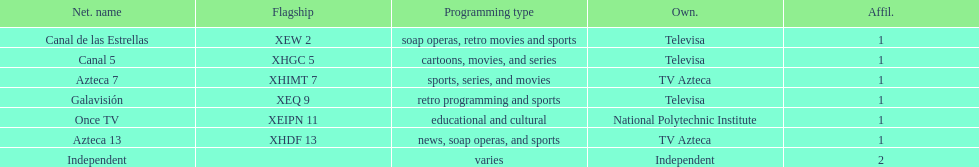What is the average number of affiliates that a given network will have? 1. 